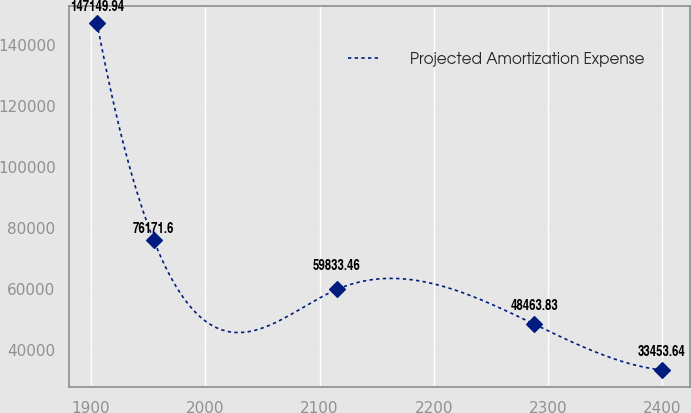Convert chart. <chart><loc_0><loc_0><loc_500><loc_500><line_chart><ecel><fcel>Projected Amortization Expense<nl><fcel>1905.21<fcel>147150<nl><fcel>1954.63<fcel>76171.6<nl><fcel>2115.04<fcel>59833.5<nl><fcel>2287.84<fcel>48463.8<nl><fcel>2399.37<fcel>33453.6<nl></chart> 